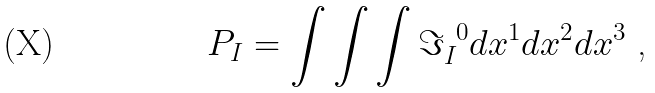<formula> <loc_0><loc_0><loc_500><loc_500>P _ { I } = \int \int \int { \Im } _ { I } ^ { \ 0 } d x ^ { 1 } d x ^ { 2 } d x ^ { 3 } \text {\ ,}</formula> 